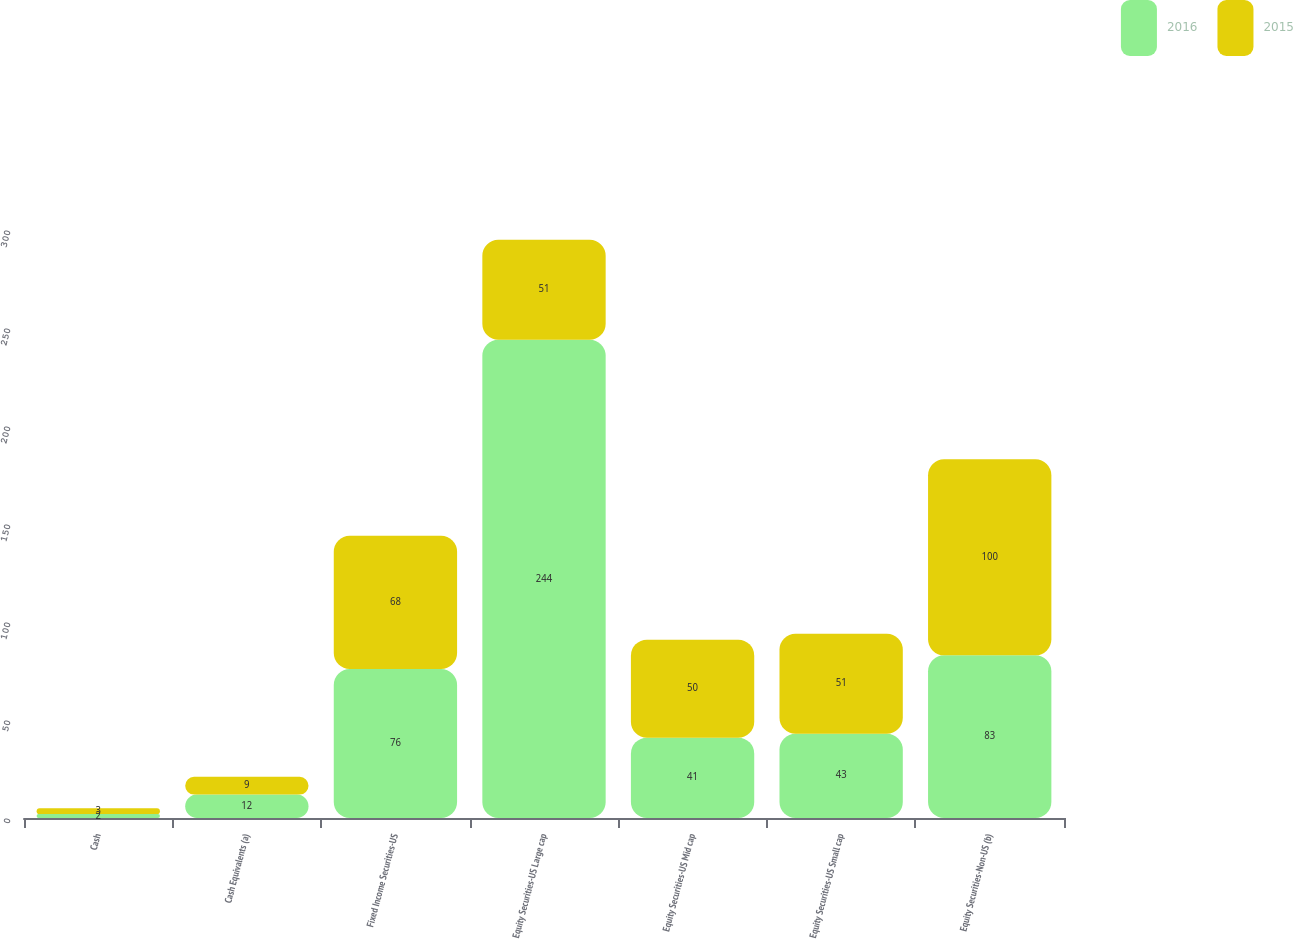Convert chart to OTSL. <chart><loc_0><loc_0><loc_500><loc_500><stacked_bar_chart><ecel><fcel>Cash<fcel>Cash Equivalents (a)<fcel>Fixed Income Securities-US<fcel>Equity Securities-US Large cap<fcel>Equity Securities-US Mid cap<fcel>Equity Securities-US Small cap<fcel>Equity Securities-Non-US (b)<nl><fcel>2016<fcel>2<fcel>12<fcel>76<fcel>244<fcel>41<fcel>43<fcel>83<nl><fcel>2015<fcel>3<fcel>9<fcel>68<fcel>51<fcel>50<fcel>51<fcel>100<nl></chart> 